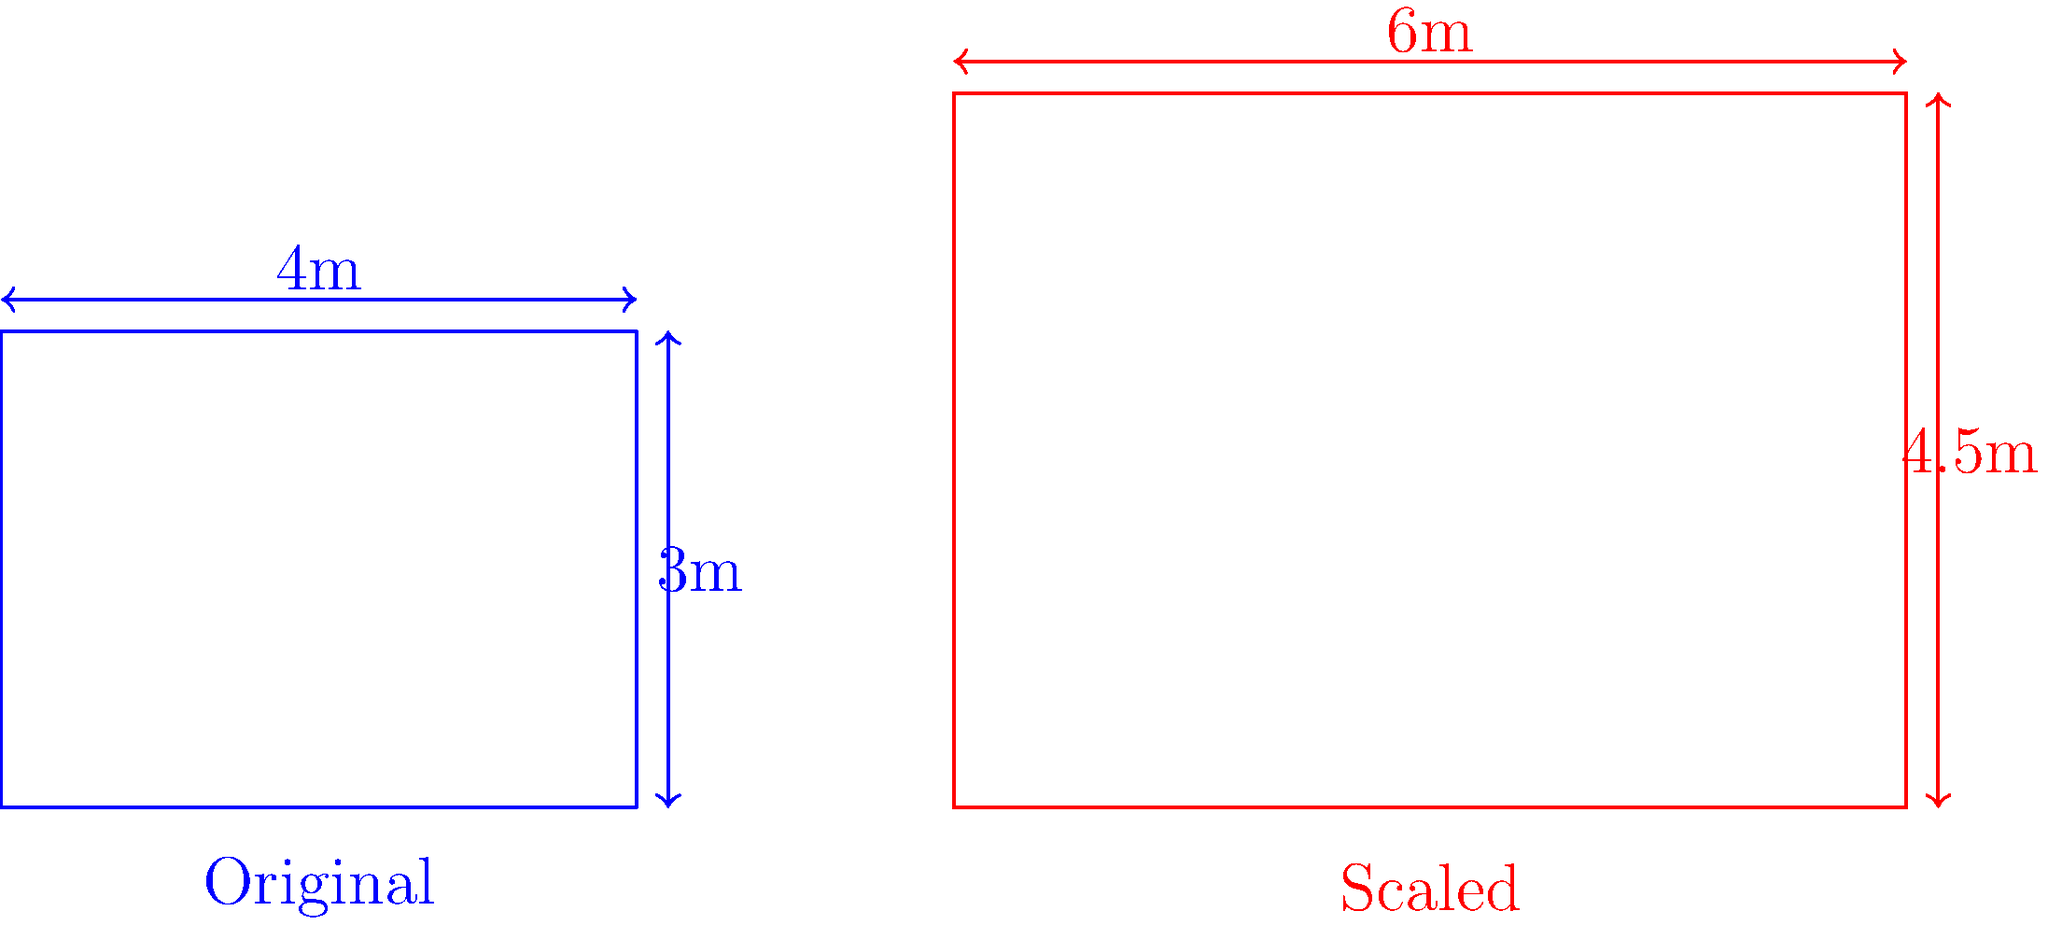A blueprint for a small storage unit needs to be altered to appear larger for a potential scam. The original dimensions are 4m x 3m. If the length is increased by 50% in the forged blueprint, what should the new height be to maintain the same proportions? Round your answer to one decimal place. To solve this problem, we need to follow these steps:

1) First, let's identify the scale factor for the length:
   New length = 6m (50% increase from 4m)
   Scale factor = 6m / 4m = 1.5

2) To maintain the same proportions, we need to apply this scale factor to the height as well:
   New height = Original height × Scale factor
               = 3m × 1.5
               = 4.5m

3) The question asks to round to one decimal place, but 4.5m is already in that form.

Therefore, to maintain the same proportions when the length is increased by 50%, the height should be scaled to 4.5m.
Answer: 4.5m 